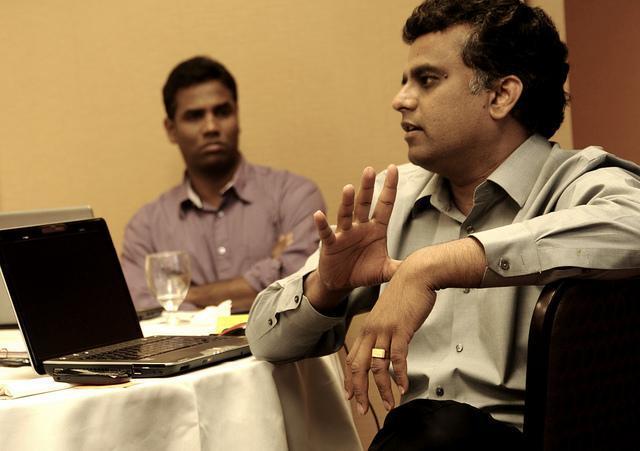How many men have white hair?
Give a very brief answer. 0. How many maps are visible on the walls?
Give a very brief answer. 0. How many people are using laptops?
Give a very brief answer. 2. How many people can you see?
Give a very brief answer. 2. How many dining tables can you see?
Give a very brief answer. 1. How many animals that are zebras are there? there are animals that aren't zebras too?
Give a very brief answer. 0. 